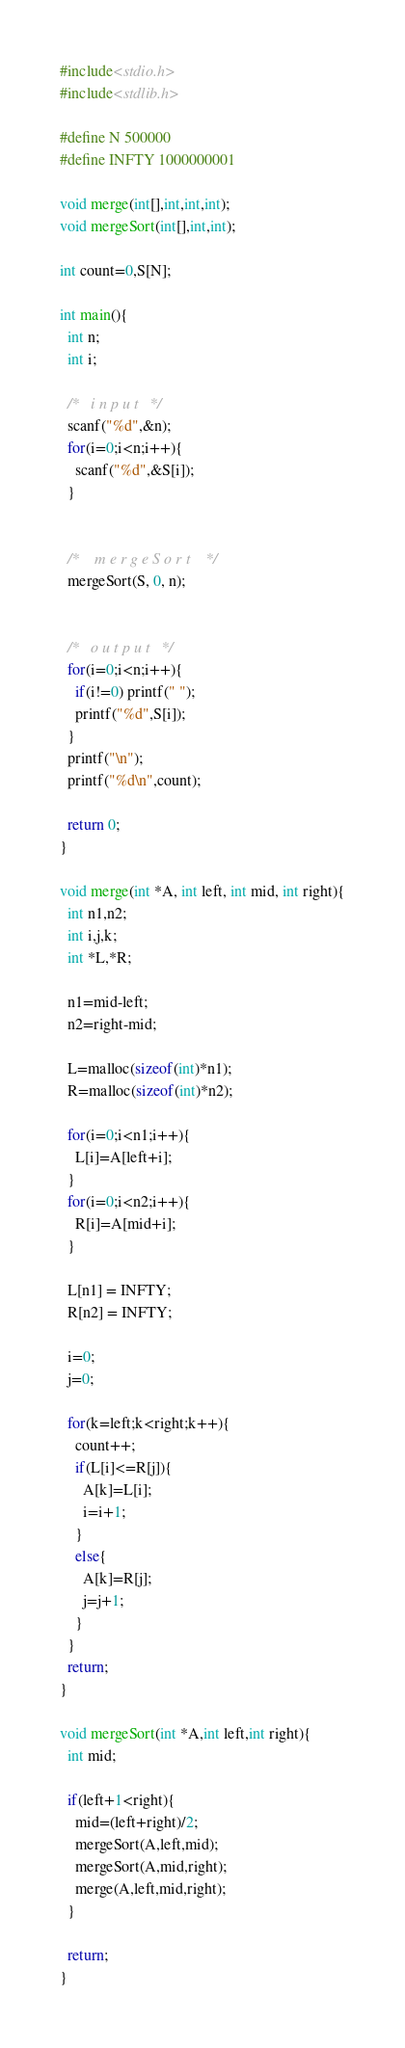Convert code to text. <code><loc_0><loc_0><loc_500><loc_500><_C_>#include<stdio.h>
#include<stdlib.h>

#define N 500000
#define INFTY 1000000001

void merge(int[],int,int,int);
void mergeSort(int[],int,int);

int count=0,S[N];

int main(){
  int n;
  int i;

  /*   i n p u t   */
  scanf("%d",&n);
  for(i=0;i<n;i++){
    scanf("%d",&S[i]);
  }


  /*    m e r g e S o r t    */
  mergeSort(S, 0, n);


  /*   o u t p u t   */
  for(i=0;i<n;i++){
    if(i!=0) printf(" ");
    printf("%d",S[i]);
  }
  printf("\n");
  printf("%d\n",count);

  return 0;
}

void merge(int *A, int left, int mid, int right){
  int n1,n2;
  int i,j,k;
  int *L,*R;

  n1=mid-left;
  n2=right-mid;

  L=malloc(sizeof(int)*n1);
  R=malloc(sizeof(int)*n2);

  for(i=0;i<n1;i++){
    L[i]=A[left+i];
  }
  for(i=0;i<n2;i++){
    R[i]=A[mid+i];
  }

  L[n1] = INFTY;
  R[n2] = INFTY;

  i=0;
  j=0;

  for(k=left;k<right;k++){
    count++;
    if(L[i]<=R[j]){
      A[k]=L[i];
      i=i+1;
    }
    else{
      A[k]=R[j];
      j=j+1;
    }
  }
  return;
}

void mergeSort(int *A,int left,int right){
  int mid;

  if(left+1<right){
    mid=(left+right)/2;
    mergeSort(A,left,mid);
    mergeSort(A,mid,right);
    merge(A,left,mid,right);
  }

  return;
}</code> 